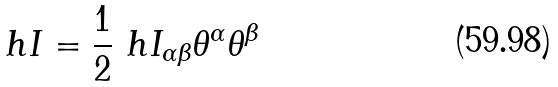Convert formula to latex. <formula><loc_0><loc_0><loc_500><loc_500>\ h { I } = \frac { 1 } { 2 } \ h { I } _ { \alpha \beta } \theta ^ { \alpha } \theta ^ { \beta }</formula> 